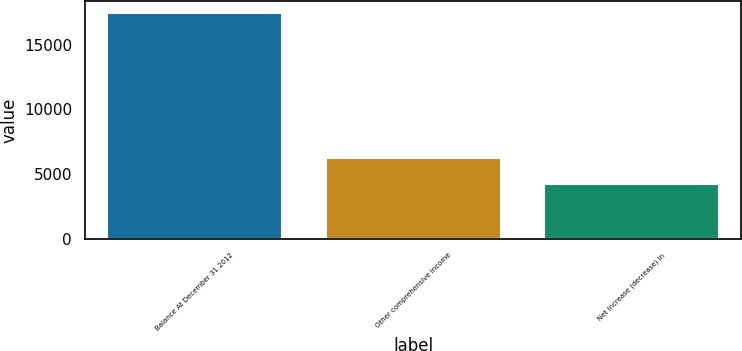Convert chart. <chart><loc_0><loc_0><loc_500><loc_500><bar_chart><fcel>Balance At December 31 2012<fcel>Other comprehensive income<fcel>Net increase (decrease) in<nl><fcel>17481<fcel>6234<fcel>4272<nl></chart> 